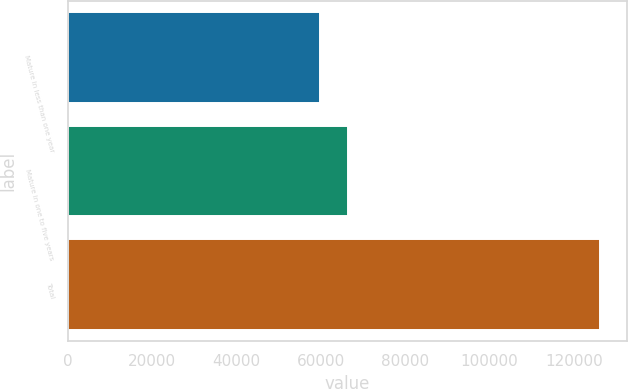Convert chart. <chart><loc_0><loc_0><loc_500><loc_500><bar_chart><fcel>Mature in less than one year<fcel>Mature in one to five years<fcel>Total<nl><fcel>59900<fcel>66536.7<fcel>126267<nl></chart> 